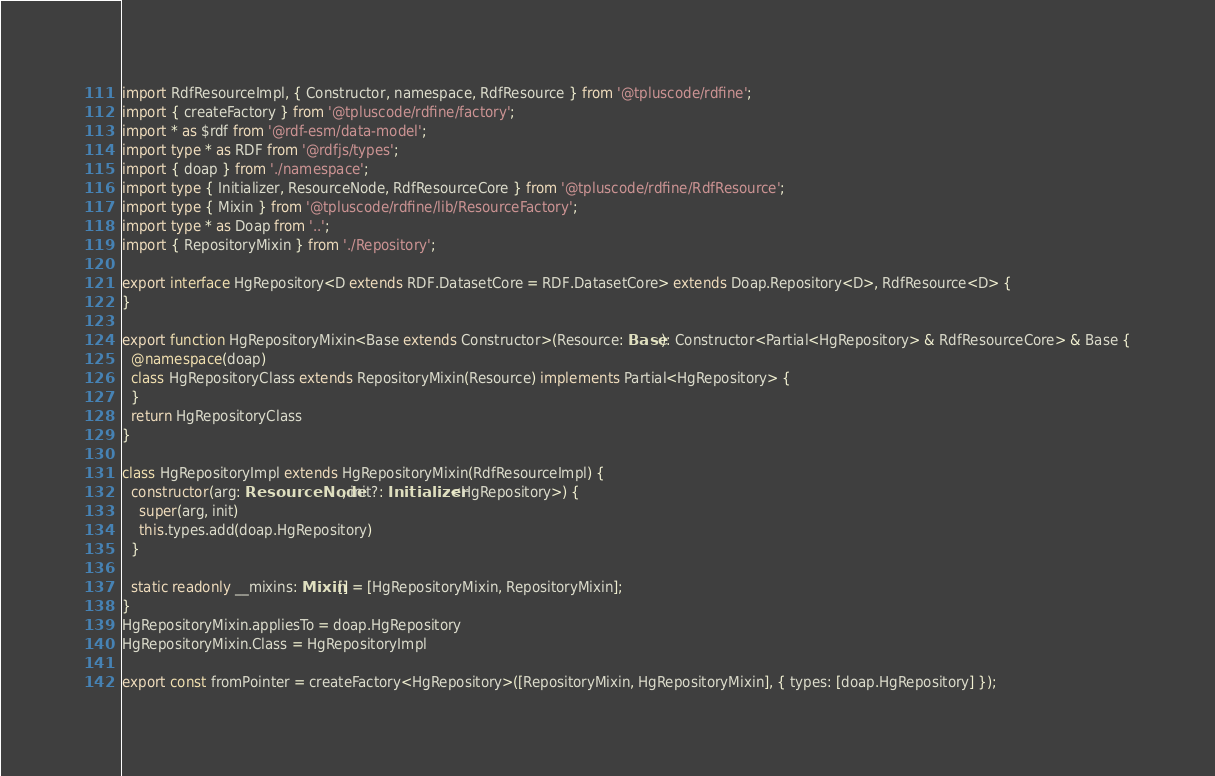<code> <loc_0><loc_0><loc_500><loc_500><_TypeScript_>import RdfResourceImpl, { Constructor, namespace, RdfResource } from '@tpluscode/rdfine';
import { createFactory } from '@tpluscode/rdfine/factory';
import * as $rdf from '@rdf-esm/data-model';
import type * as RDF from '@rdfjs/types';
import { doap } from './namespace';
import type { Initializer, ResourceNode, RdfResourceCore } from '@tpluscode/rdfine/RdfResource';
import type { Mixin } from '@tpluscode/rdfine/lib/ResourceFactory';
import type * as Doap from '..';
import { RepositoryMixin } from './Repository';

export interface HgRepository<D extends RDF.DatasetCore = RDF.DatasetCore> extends Doap.Repository<D>, RdfResource<D> {
}

export function HgRepositoryMixin<Base extends Constructor>(Resource: Base): Constructor<Partial<HgRepository> & RdfResourceCore> & Base {
  @namespace(doap)
  class HgRepositoryClass extends RepositoryMixin(Resource) implements Partial<HgRepository> {
  }
  return HgRepositoryClass
}

class HgRepositoryImpl extends HgRepositoryMixin(RdfResourceImpl) {
  constructor(arg: ResourceNode, init?: Initializer<HgRepository>) {
    super(arg, init)
    this.types.add(doap.HgRepository)
  }

  static readonly __mixins: Mixin[] = [HgRepositoryMixin, RepositoryMixin];
}
HgRepositoryMixin.appliesTo = doap.HgRepository
HgRepositoryMixin.Class = HgRepositoryImpl

export const fromPointer = createFactory<HgRepository>([RepositoryMixin, HgRepositoryMixin], { types: [doap.HgRepository] });
</code> 